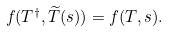<formula> <loc_0><loc_0><loc_500><loc_500>f ( T ^ { \dagger } , \widetilde { T } ( s ) ) = f ( T , s ) .</formula> 